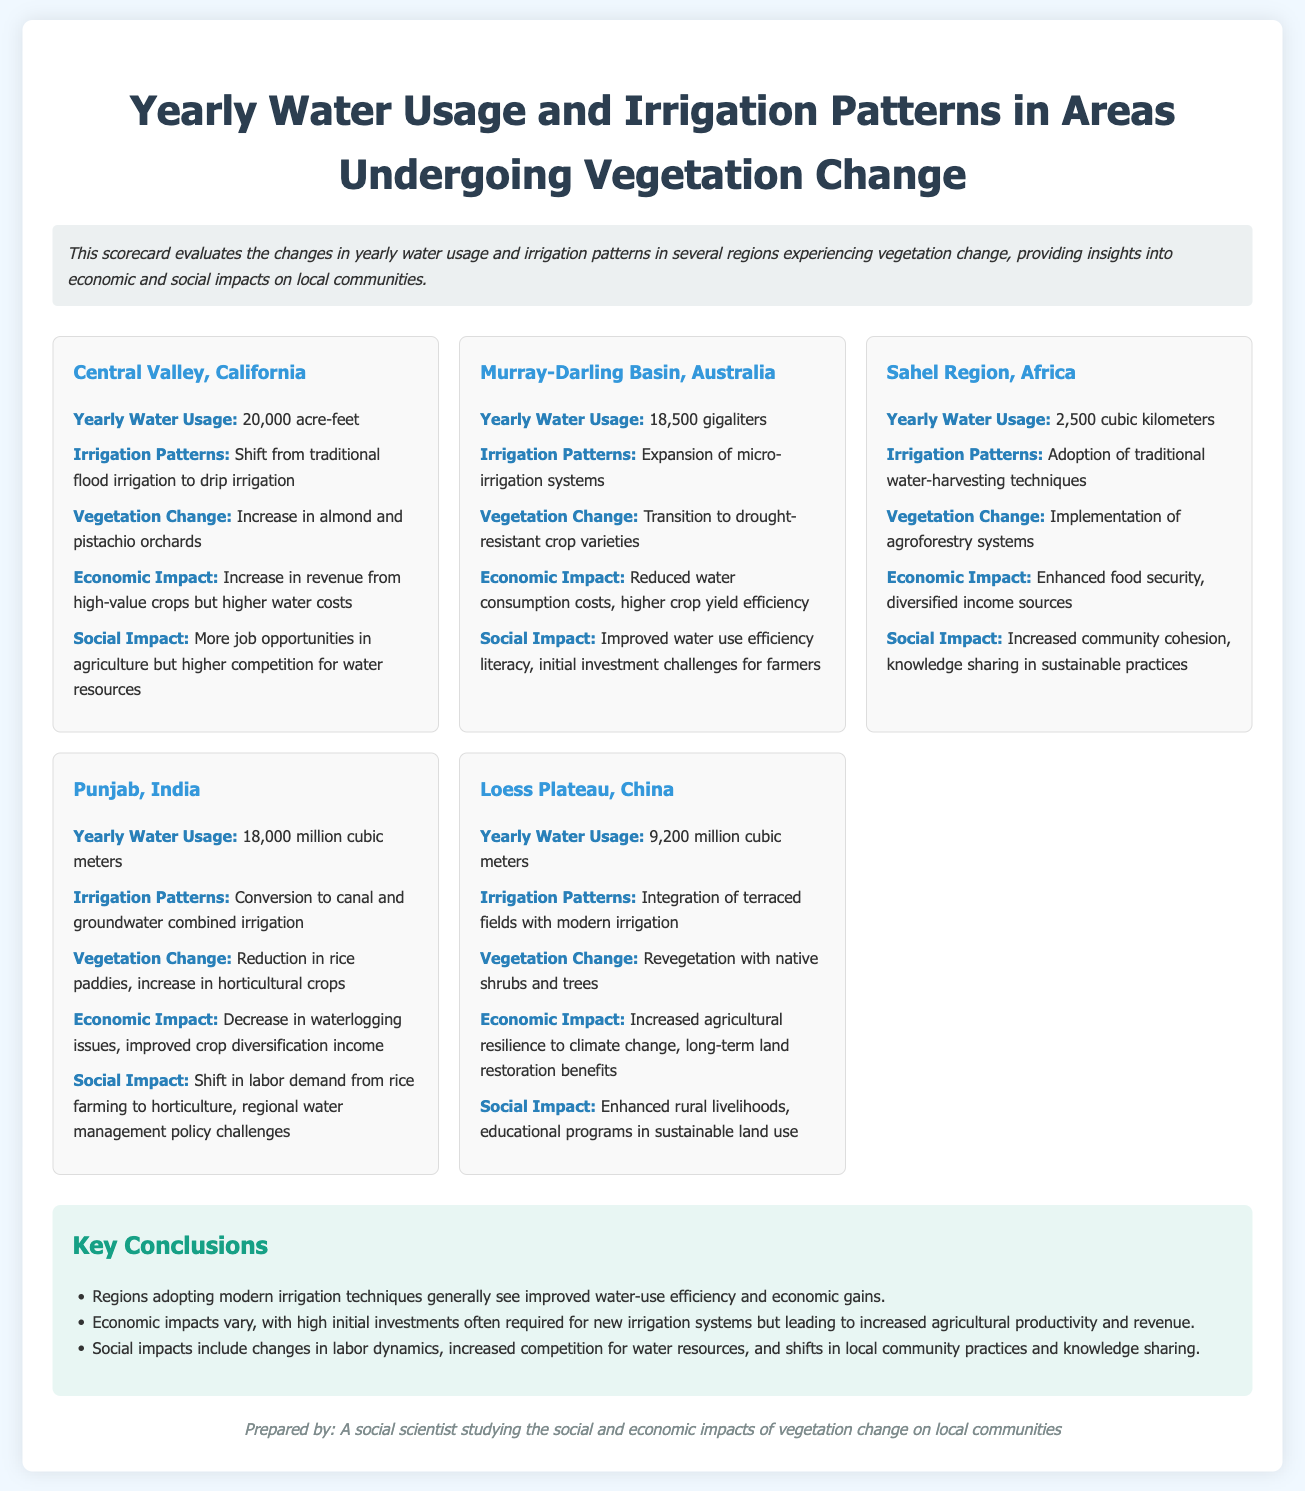What is the yearly water usage in Central Valley, California? The document states that Central Valley, California uses 20,000 acre-feet of water yearly.
Answer: 20,000 acre-feet What type of irrigation pattern is being adopted in the Murray-Darling Basin? The document mentions that the Murray-Darling Basin has expanded micro-irrigation systems as its irrigation pattern.
Answer: Expansion of micro-irrigation systems What economic impact is noted for the Sahel Region, Africa? According to the document, the Sahel Region has enhanced food security and diversified income sources as its economic impact.
Answer: Enhanced food security, diversified income sources What vegetation change is observed in Punjab, India? The document indicates that Punjab has experienced a reduction in rice paddies and an increase in horticultural crops.
Answer: Reduction in rice paddies, increase in horticultural crops How many million cubic meters of water does the Loess Plateau, China use yearly? The document reports that the Loess Plateau uses 9,200 million cubic meters of water each year.
Answer: 9,200 million cubic meters What is a key conclusion regarding modern irrigation techniques? The document concludes that regions adopting modern irrigation techniques see improved water-use efficiency and economic gains.
Answer: Improved water-use efficiency and economic gains What social impact is mentioned for the Central Valley, California? The document notes that in Central Valley, California, there are more job opportunities in agriculture but higher competition for water resources.
Answer: More job opportunities, higher competition for water resources Which region is transitioning to drought-resistant crop varieties? The document highlights that the Murray-Darling Basin is transitioning to drought-resistant crop varieties.
Answer: Murray-Darling Basin What type of document is this? The content of the document indicates it is a "Scorecard" evaluating water usage and irrigation patterns.
Answer: Scorecard 